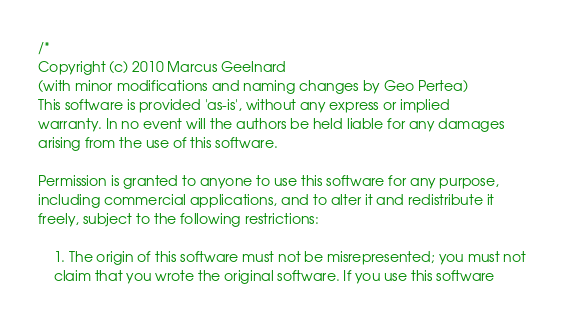Convert code to text. <code><loc_0><loc_0><loc_500><loc_500><_C++_>/*
Copyright (c) 2010 Marcus Geelnard
(with minor modifications and naming changes by Geo Pertea)
This software is provided 'as-is', without any express or implied
warranty. In no event will the authors be held liable for any damages
arising from the use of this software.

Permission is granted to anyone to use this software for any purpose,
including commercial applications, and to alter it and redistribute it
freely, subject to the following restrictions:

    1. The origin of this software must not be misrepresented; you must not
    claim that you wrote the original software. If you use this software</code> 